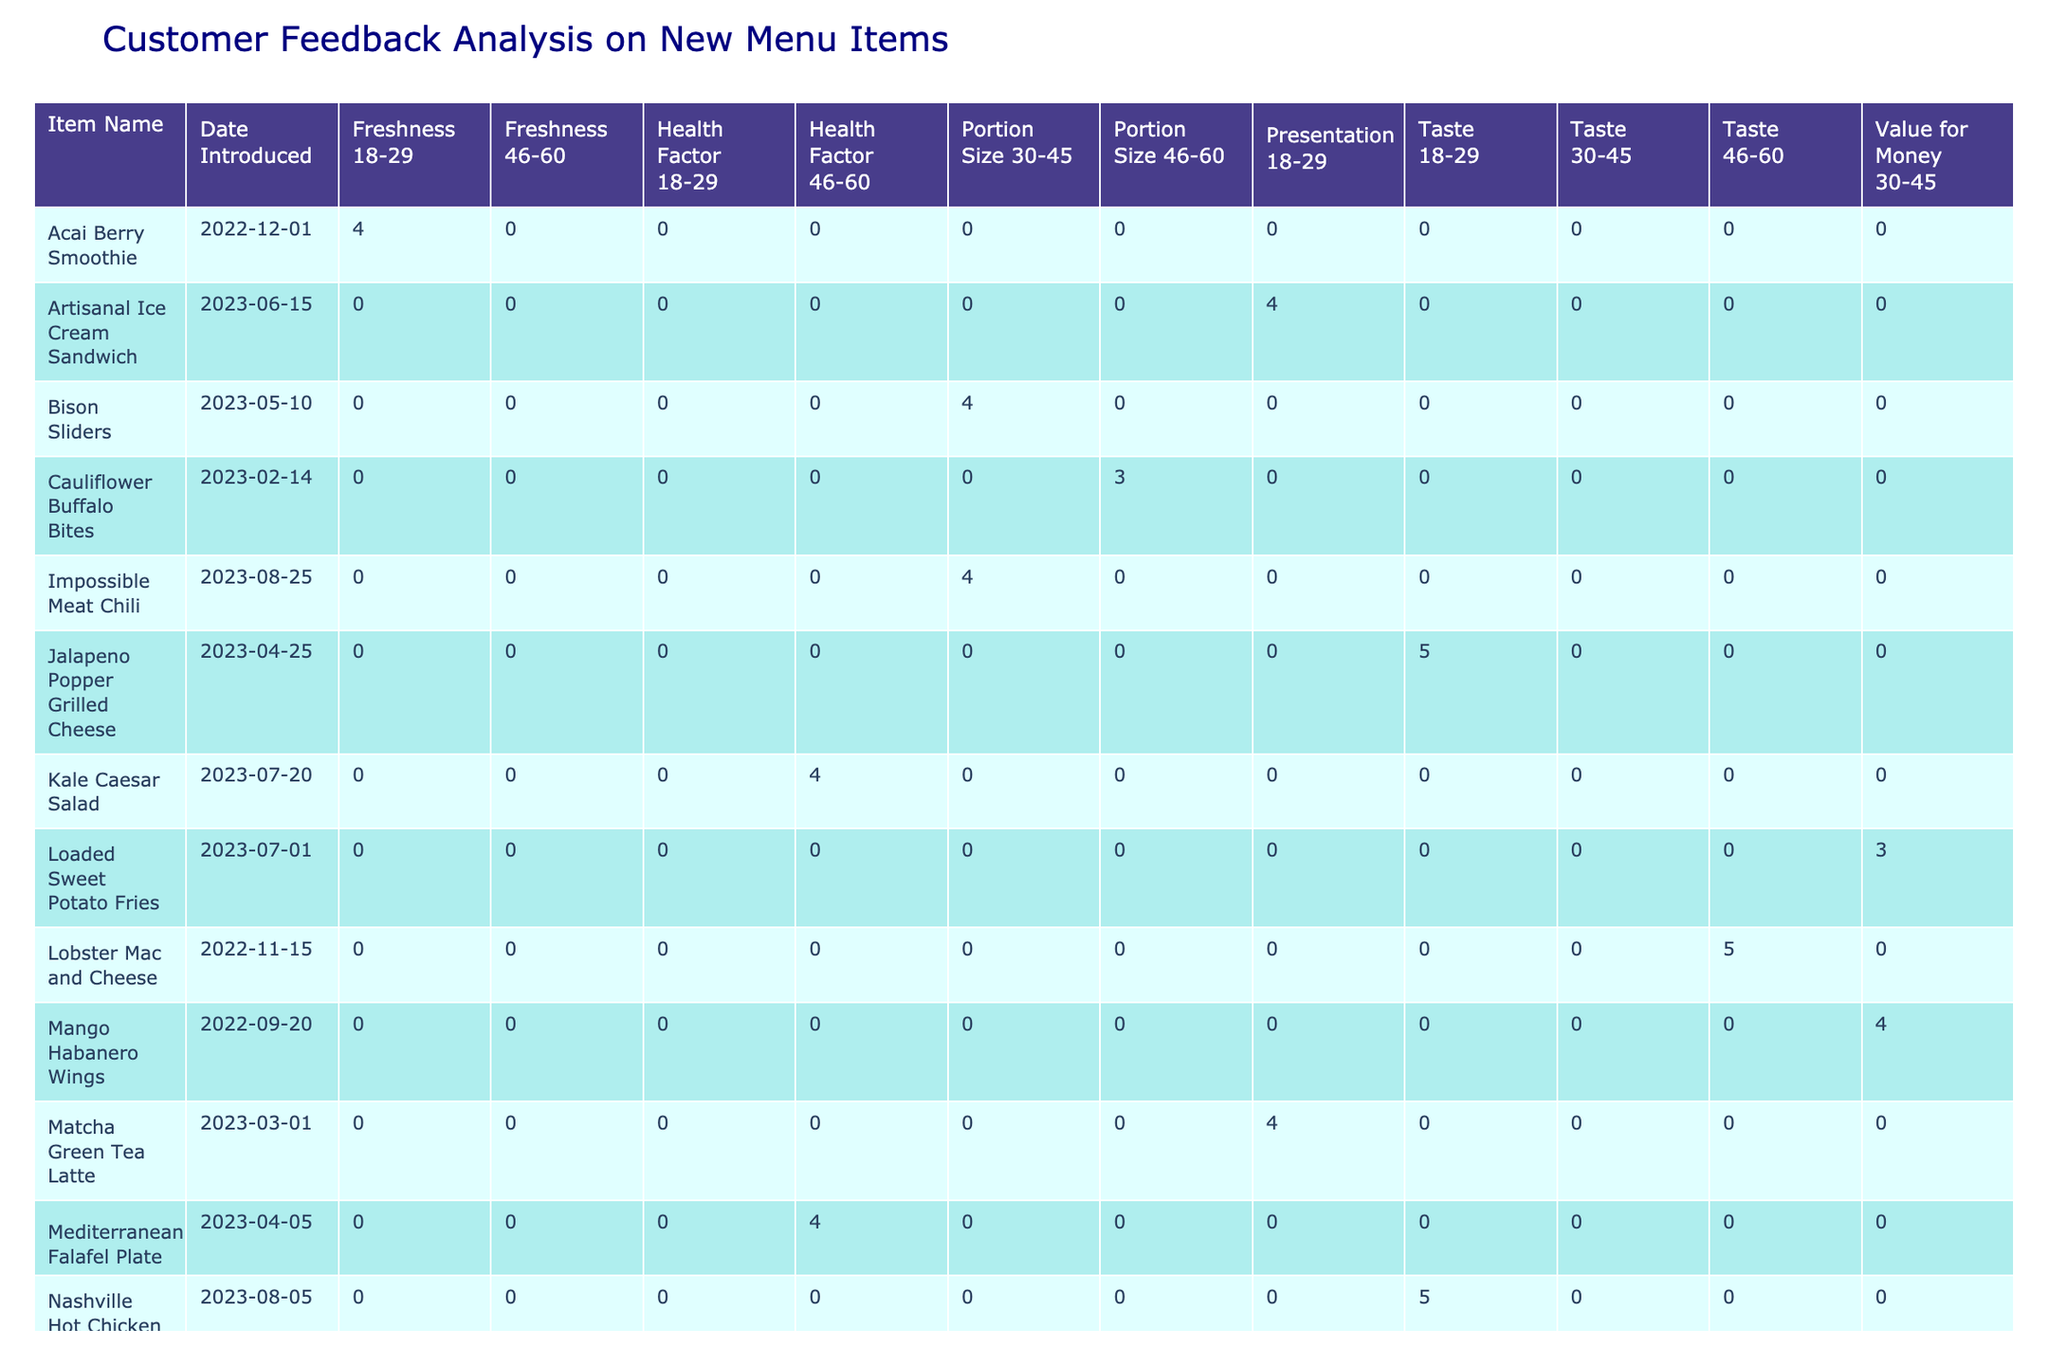What is the customer rating for the Vegan Jackfruit Wrap? The customer rating for the Vegan Jackfruit Wrap is found by looking at the specific row that mentions this item. According to the table, it shows a rating of 3.
Answer: 3 Which menu item received the highest customer rating? To find the highest rating, we look through the 'Customer Rating' column to find the maximum value. The Truffle Mushroom Burger, Quinoa Power Bowl, Lobster Mac and Cheese, Pulled Pork Poutine, Sriracha Shrimp Tacos, Jalapeno Popper Grilled Cheese, Vietnamese Banh Mi Sandwich, Nashville Hot Chicken Sandwich all received a rating of 5, which is the highest.
Answer: Truffle Mushroom Burger, Quinoa Power Bowl, Lobster Mac and Cheese, Pulled Pork Poutine, Sriracha Shrimp Tacos, Jalapeno Popper Grilled Cheese, Vietnamese Banh Mi Sandwich, Nashville Hot Chicken Sandwich How many items have a rating of 4 in the Taste category? By filtering the table to only look at the Taste feedback type, we count how many items have a rating of 4. The items that match this are Spicy Korean Taco, Mango Habanero Wings, Pulled Pork Poutine, and Nashville Hot Chicken Sandwich, totaling four items.
Answer: 4 What is the average rating for items categorized under Presentation? We first list the ratings for all items under the Presentation category: Truffle Mushroom Burger (5), Matcha Green Tea Latte (4), Artisanal Ice Cream Sandwich (4). Then we calculate the average by summing these ratings (5 + 4 + 4 = 13) and dividing by the number of items (which is 3). Thus, 13/3 equals approximately 4.33.
Answer: 4.33 Did the Cauliflower Buffalo Bites receive a rating of 5? We can find the row for the Cauliflower Buffalo Bites in the table and check its rating. It shows a rating of 3, which means it did not receive a rating of 5.
Answer: No How many items introduced after January 2023 received a rating of 4 or higher? We filter for items introduced after January 2023, which are: Sriracha Shrimp Tacos, Jalapeno Popper Grilled Cheese, Vietnamese Banh Mi Sandwich, Kale Caesar Salad, Nashville Hot Chicken Sandwich, and Impossible Meat Chili. Next, we check the ratings: Sriracha Shrimp Tacos (5), Jalapeno Popper Grilled Cheese (5), Vietnamese Banh Mi Sandwich (5), Kale Caesar Salad (4), and Impossible Meat Chili (4). All 5 of these items received a rating of 4 or higher.
Answer: 5 What feedback type is associated with the Lobster Mac and Cheese? To find this, we check the row associated with Lobster Mac and Cheese. The feedback type listed there is Taste.
Answer: Taste How many unique age groups provided feedback on the new menu items? By examining the age group column, we note the distinct entries listed: 18-29, 30-45, and 46-60. Therefore, we count these unique groups resulting in a total of three age groups that provided feedback.
Answer: 3 What is the total number of menu items introduced in March 2023 and their average rating? Looking at the March 2023 entries, we see Sriracha Shrimp Tacos and Matcha Green Tea Latte, making a total of two items. Their ratings are 5 and 4 respectively, totaling 9. Thus, average rating is calculated as 9/2, resulting in 4.5.
Answer: 2, 4.5 